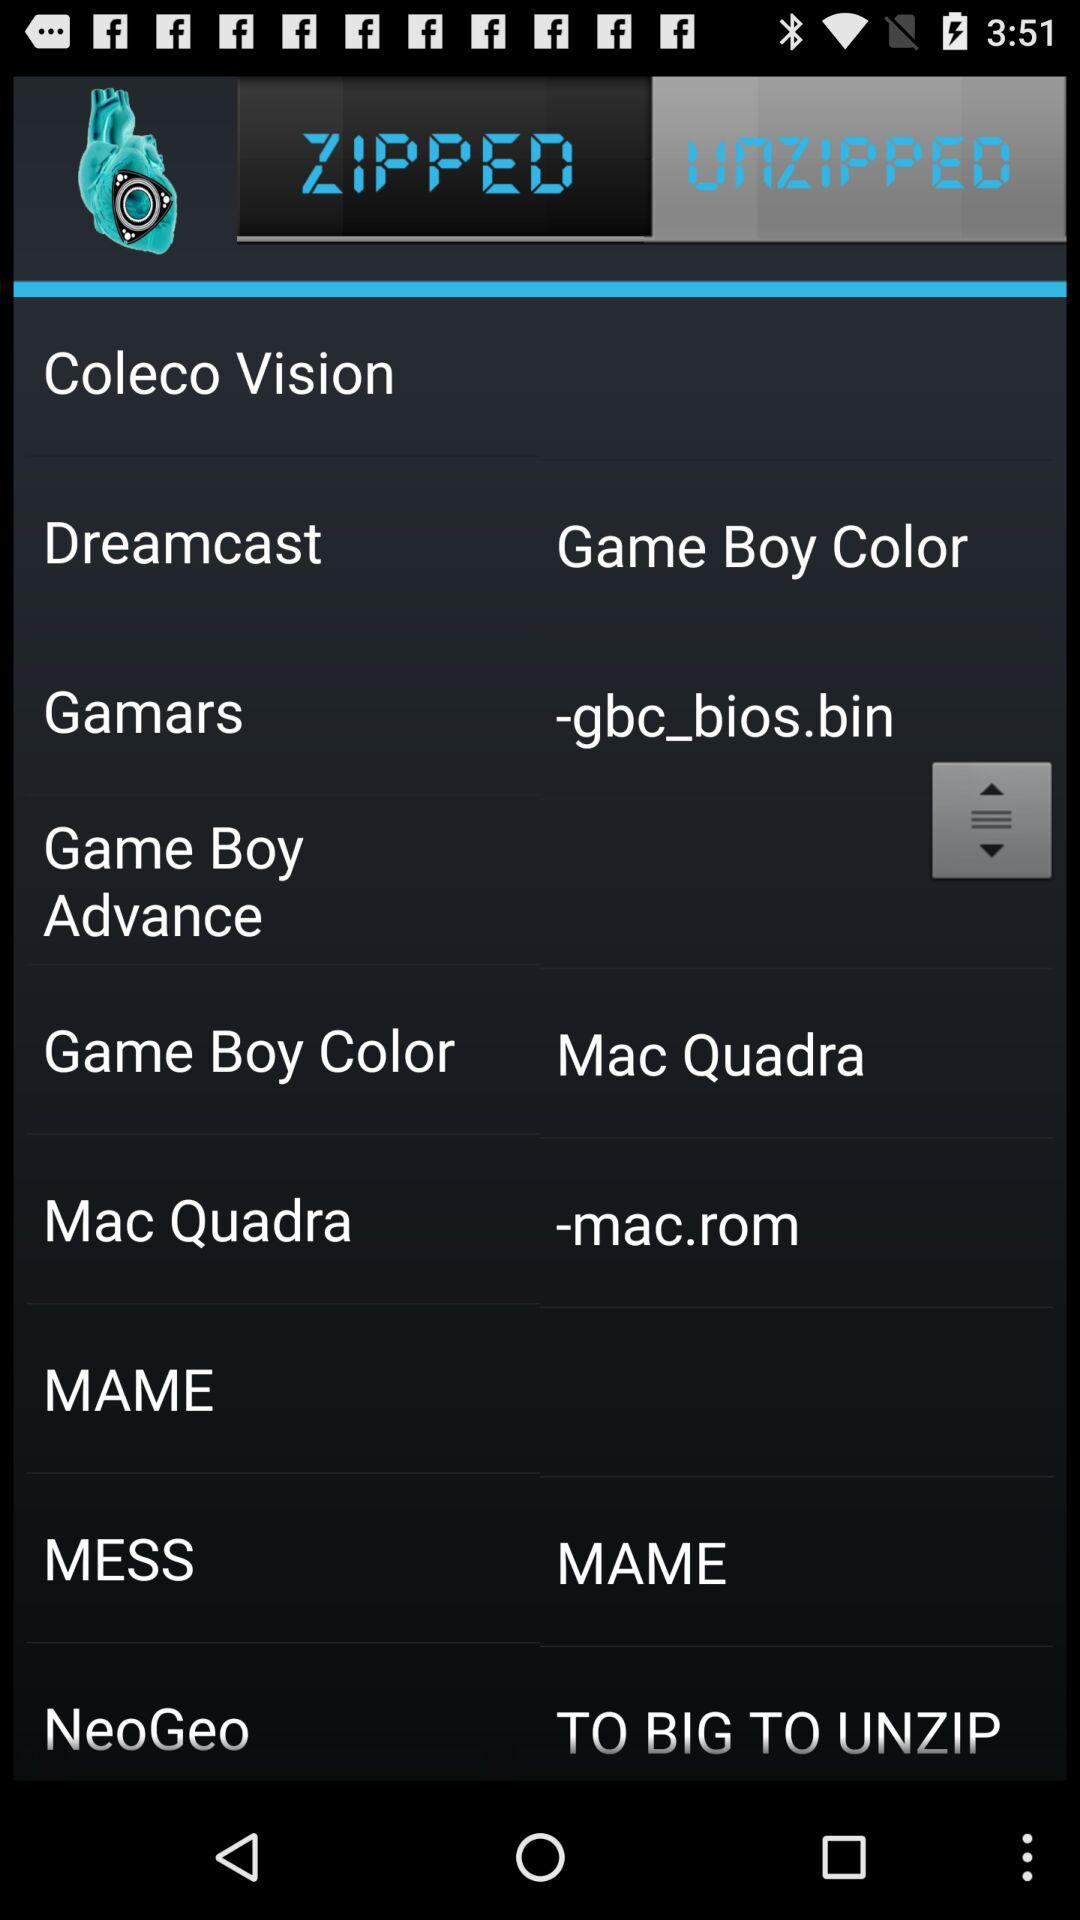Which tab is selected? The selected tab is "UNZIPPED". 